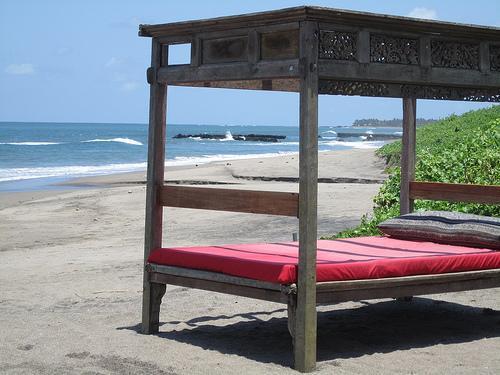How many beds are there?
Give a very brief answer. 1. 